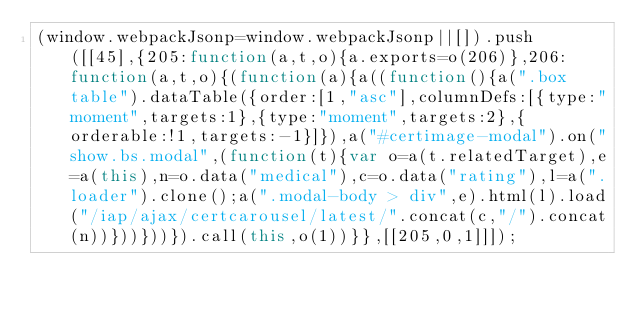<code> <loc_0><loc_0><loc_500><loc_500><_JavaScript_>(window.webpackJsonp=window.webpackJsonp||[]).push([[45],{205:function(a,t,o){a.exports=o(206)},206:function(a,t,o){(function(a){a((function(){a(".box table").dataTable({order:[1,"asc"],columnDefs:[{type:"moment",targets:1},{type:"moment",targets:2},{orderable:!1,targets:-1}]}),a("#certimage-modal").on("show.bs.modal",(function(t){var o=a(t.relatedTarget),e=a(this),n=o.data("medical"),c=o.data("rating"),l=a(".loader").clone();a(".modal-body > div",e).html(l).load("/iap/ajax/certcarousel/latest/".concat(c,"/").concat(n))}))}))}).call(this,o(1))}},[[205,0,1]]]);</code> 